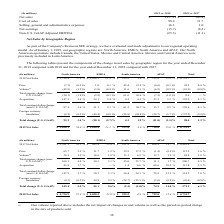According to Sealed Air Corporation's financial document, What currency is translated to by the company for financial results? Based on the financial document, the answer is US Dollars. Also, Historically, what currencies have impacted  the translation of their consolidated financial results most significantly? Based on the financial document, the answer is euro, the Australian dollar, the Mexican peso, the British pound, the Canadian dollar, the Brazilian real and the Chinese Renminbi.. Also, What does the table show? Based on the financial document, the answer is The following table presents the approximate favorable or (unfavorable) impact foreign currency translation had on certain of our consolidated financial results. Also, can you calculate: What is the total favourable impact foreign currency translation had on certain of their consolidated financial results?  Based on the calculation: 98.4+31.7+16.3+1.0, the result is 147.4 (in millions). This is based on the information: "Cost of sales 98.4 31.7 Selling, general and administrative expenses 16.3 1.0 Selling, general and administrative expenses 16.3 1.0 Cost of sales 98.4 31.7..." The key data points involved are: 1.0, 16.3, 31.7. Also, can you calculate: What is the difference between the impact of cost of sales for 2019 vs. 2018 and 2018 vs. 2017? Based on the calculation: 98.4-31.7, the result is 66.7 (in millions). This is based on the information: "Cost of sales 98.4 31.7 Cost of sales 98.4 31.7..." The key data points involved are: 31.7, 98.4. Also, can you calculate: What is the percentage change of the impact of Net sales of 2019 vs. 2018 from 2018 vs. 2017? To answer this question, I need to perform calculations using the financial data. The calculation is: (137.2-43.4)/43.4, which equals 216.13 (percentage). This is based on the information: "illions) 2019 vs. 2018 2018 vs. 2017 Net sales $ (137.2) $ (43.4) 019 vs. 2018 2018 vs. 2017 Net sales $ (137.2) $ (43.4)..." The key data points involved are: 137.2, 43.4. 